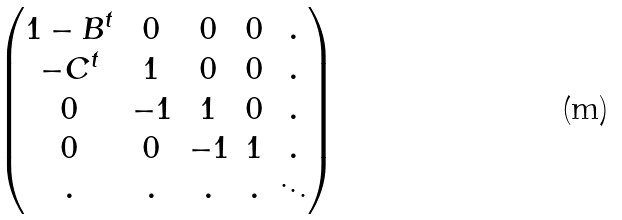Convert formula to latex. <formula><loc_0><loc_0><loc_500><loc_500>\begin{pmatrix} 1 - B ^ { t } & 0 & 0 & 0 & . \\ - C ^ { t } & 1 & 0 & 0 & . \\ 0 & - 1 & 1 & 0 & . \\ 0 & 0 & - 1 & 1 & . \\ . & . & . & . & \ddots \end{pmatrix}</formula> 